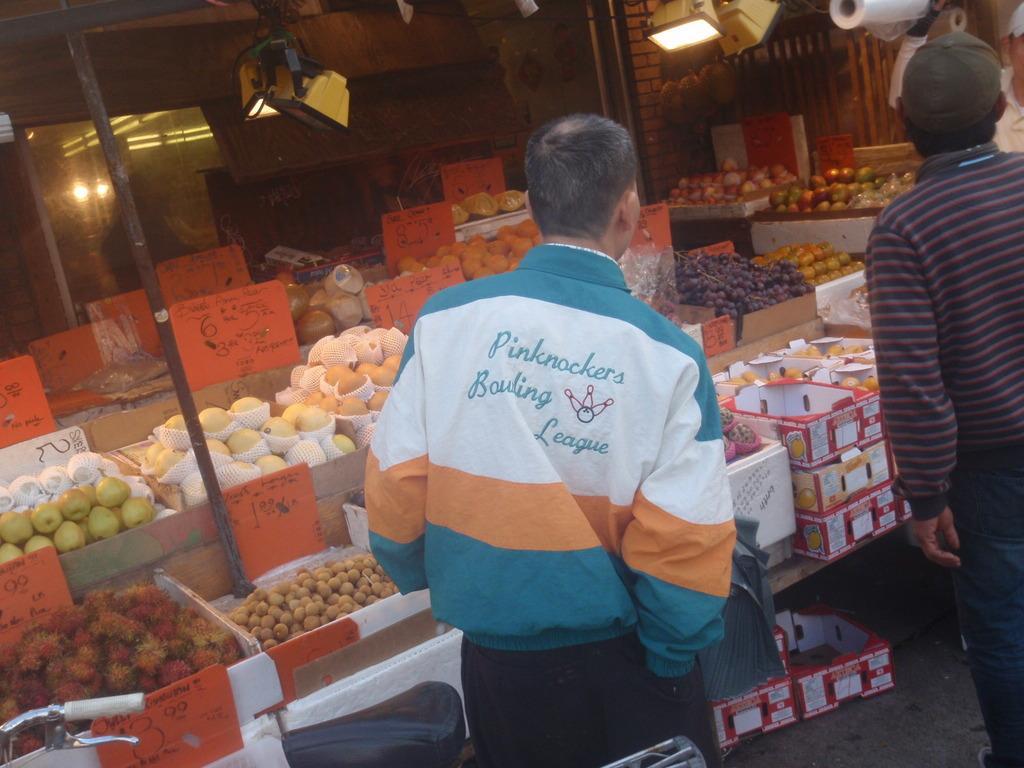In one or two sentences, can you explain what this image depicts? In this picture we can see two people standing. There is a vehicle visible in the bottom left. We can see some fruits in the boxes. There is some text visible on the boards. We can see a few poles, lights and other objects in the background. 